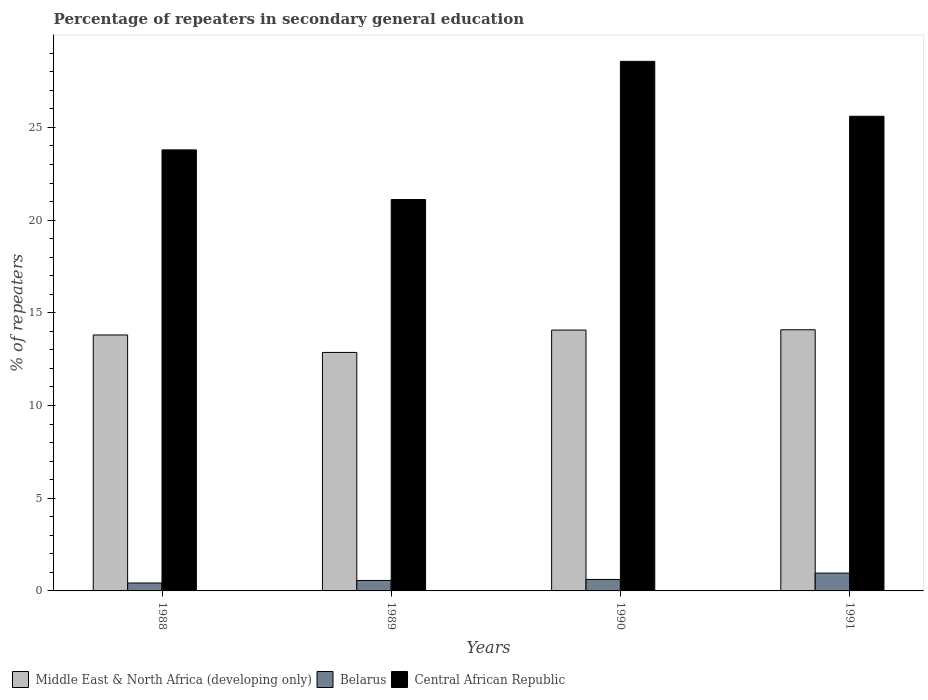How many different coloured bars are there?
Ensure brevity in your answer.  3. Are the number of bars per tick equal to the number of legend labels?
Give a very brief answer. Yes. What is the label of the 2nd group of bars from the left?
Make the answer very short. 1989. What is the percentage of repeaters in secondary general education in Belarus in 1991?
Offer a very short reply. 0.96. Across all years, what is the maximum percentage of repeaters in secondary general education in Central African Republic?
Your answer should be very brief. 28.56. Across all years, what is the minimum percentage of repeaters in secondary general education in Central African Republic?
Give a very brief answer. 21.11. In which year was the percentage of repeaters in secondary general education in Belarus minimum?
Your response must be concise. 1988. What is the total percentage of repeaters in secondary general education in Middle East & North Africa (developing only) in the graph?
Your answer should be very brief. 54.82. What is the difference between the percentage of repeaters in secondary general education in Middle East & North Africa (developing only) in 1988 and that in 1989?
Your answer should be very brief. 0.94. What is the difference between the percentage of repeaters in secondary general education in Middle East & North Africa (developing only) in 1991 and the percentage of repeaters in secondary general education in Belarus in 1990?
Your answer should be very brief. 13.47. What is the average percentage of repeaters in secondary general education in Belarus per year?
Offer a terse response. 0.64. In the year 1991, what is the difference between the percentage of repeaters in secondary general education in Central African Republic and percentage of repeaters in secondary general education in Middle East & North Africa (developing only)?
Your answer should be very brief. 11.52. What is the ratio of the percentage of repeaters in secondary general education in Central African Republic in 1989 to that in 1990?
Your answer should be compact. 0.74. Is the difference between the percentage of repeaters in secondary general education in Central African Republic in 1990 and 1991 greater than the difference between the percentage of repeaters in secondary general education in Middle East & North Africa (developing only) in 1990 and 1991?
Offer a very short reply. Yes. What is the difference between the highest and the second highest percentage of repeaters in secondary general education in Central African Republic?
Your answer should be very brief. 2.96. What is the difference between the highest and the lowest percentage of repeaters in secondary general education in Middle East & North Africa (developing only)?
Provide a short and direct response. 1.22. What does the 1st bar from the left in 1991 represents?
Provide a short and direct response. Middle East & North Africa (developing only). What does the 1st bar from the right in 1989 represents?
Give a very brief answer. Central African Republic. Is it the case that in every year, the sum of the percentage of repeaters in secondary general education in Middle East & North Africa (developing only) and percentage of repeaters in secondary general education in Belarus is greater than the percentage of repeaters in secondary general education in Central African Republic?
Your answer should be very brief. No. How many bars are there?
Ensure brevity in your answer.  12. Are the values on the major ticks of Y-axis written in scientific E-notation?
Your answer should be compact. No. Where does the legend appear in the graph?
Offer a very short reply. Bottom left. How are the legend labels stacked?
Your answer should be very brief. Horizontal. What is the title of the graph?
Your answer should be compact. Percentage of repeaters in secondary general education. Does "Cote d'Ivoire" appear as one of the legend labels in the graph?
Offer a very short reply. No. What is the label or title of the X-axis?
Ensure brevity in your answer.  Years. What is the label or title of the Y-axis?
Keep it short and to the point. % of repeaters. What is the % of repeaters in Middle East & North Africa (developing only) in 1988?
Make the answer very short. 13.8. What is the % of repeaters of Belarus in 1988?
Offer a very short reply. 0.43. What is the % of repeaters of Central African Republic in 1988?
Provide a short and direct response. 23.79. What is the % of repeaters in Middle East & North Africa (developing only) in 1989?
Provide a short and direct response. 12.86. What is the % of repeaters of Belarus in 1989?
Your answer should be very brief. 0.56. What is the % of repeaters of Central African Republic in 1989?
Make the answer very short. 21.11. What is the % of repeaters of Middle East & North Africa (developing only) in 1990?
Ensure brevity in your answer.  14.07. What is the % of repeaters in Belarus in 1990?
Your response must be concise. 0.62. What is the % of repeaters in Central African Republic in 1990?
Keep it short and to the point. 28.56. What is the % of repeaters in Middle East & North Africa (developing only) in 1991?
Offer a terse response. 14.09. What is the % of repeaters in Belarus in 1991?
Provide a succinct answer. 0.96. What is the % of repeaters in Central African Republic in 1991?
Keep it short and to the point. 25.6. Across all years, what is the maximum % of repeaters of Middle East & North Africa (developing only)?
Give a very brief answer. 14.09. Across all years, what is the maximum % of repeaters in Belarus?
Your response must be concise. 0.96. Across all years, what is the maximum % of repeaters of Central African Republic?
Keep it short and to the point. 28.56. Across all years, what is the minimum % of repeaters in Middle East & North Africa (developing only)?
Offer a very short reply. 12.86. Across all years, what is the minimum % of repeaters in Belarus?
Give a very brief answer. 0.43. Across all years, what is the minimum % of repeaters of Central African Republic?
Give a very brief answer. 21.11. What is the total % of repeaters in Middle East & North Africa (developing only) in the graph?
Make the answer very short. 54.82. What is the total % of repeaters of Belarus in the graph?
Ensure brevity in your answer.  2.57. What is the total % of repeaters in Central African Republic in the graph?
Make the answer very short. 99.06. What is the difference between the % of repeaters of Middle East & North Africa (developing only) in 1988 and that in 1989?
Give a very brief answer. 0.94. What is the difference between the % of repeaters of Belarus in 1988 and that in 1989?
Offer a very short reply. -0.14. What is the difference between the % of repeaters of Central African Republic in 1988 and that in 1989?
Give a very brief answer. 2.68. What is the difference between the % of repeaters in Middle East & North Africa (developing only) in 1988 and that in 1990?
Keep it short and to the point. -0.26. What is the difference between the % of repeaters in Belarus in 1988 and that in 1990?
Your answer should be compact. -0.19. What is the difference between the % of repeaters of Central African Republic in 1988 and that in 1990?
Your answer should be very brief. -4.78. What is the difference between the % of repeaters of Middle East & North Africa (developing only) in 1988 and that in 1991?
Give a very brief answer. -0.28. What is the difference between the % of repeaters in Belarus in 1988 and that in 1991?
Your answer should be compact. -0.53. What is the difference between the % of repeaters in Central African Republic in 1988 and that in 1991?
Your answer should be compact. -1.81. What is the difference between the % of repeaters of Middle East & North Africa (developing only) in 1989 and that in 1990?
Make the answer very short. -1.21. What is the difference between the % of repeaters in Belarus in 1989 and that in 1990?
Ensure brevity in your answer.  -0.05. What is the difference between the % of repeaters in Central African Republic in 1989 and that in 1990?
Your response must be concise. -7.45. What is the difference between the % of repeaters of Middle East & North Africa (developing only) in 1989 and that in 1991?
Give a very brief answer. -1.22. What is the difference between the % of repeaters of Belarus in 1989 and that in 1991?
Make the answer very short. -0.4. What is the difference between the % of repeaters in Central African Republic in 1989 and that in 1991?
Your answer should be very brief. -4.49. What is the difference between the % of repeaters of Middle East & North Africa (developing only) in 1990 and that in 1991?
Your answer should be compact. -0.02. What is the difference between the % of repeaters of Belarus in 1990 and that in 1991?
Offer a terse response. -0.34. What is the difference between the % of repeaters of Central African Republic in 1990 and that in 1991?
Make the answer very short. 2.96. What is the difference between the % of repeaters in Middle East & North Africa (developing only) in 1988 and the % of repeaters in Belarus in 1989?
Give a very brief answer. 13.24. What is the difference between the % of repeaters in Middle East & North Africa (developing only) in 1988 and the % of repeaters in Central African Republic in 1989?
Keep it short and to the point. -7.31. What is the difference between the % of repeaters in Belarus in 1988 and the % of repeaters in Central African Republic in 1989?
Offer a very short reply. -20.68. What is the difference between the % of repeaters of Middle East & North Africa (developing only) in 1988 and the % of repeaters of Belarus in 1990?
Give a very brief answer. 13.19. What is the difference between the % of repeaters in Middle East & North Africa (developing only) in 1988 and the % of repeaters in Central African Republic in 1990?
Make the answer very short. -14.76. What is the difference between the % of repeaters of Belarus in 1988 and the % of repeaters of Central African Republic in 1990?
Offer a terse response. -28.14. What is the difference between the % of repeaters in Middle East & North Africa (developing only) in 1988 and the % of repeaters in Belarus in 1991?
Your answer should be very brief. 12.84. What is the difference between the % of repeaters in Middle East & North Africa (developing only) in 1988 and the % of repeaters in Central African Republic in 1991?
Your answer should be compact. -11.8. What is the difference between the % of repeaters in Belarus in 1988 and the % of repeaters in Central African Republic in 1991?
Provide a short and direct response. -25.17. What is the difference between the % of repeaters of Middle East & North Africa (developing only) in 1989 and the % of repeaters of Belarus in 1990?
Keep it short and to the point. 12.24. What is the difference between the % of repeaters in Middle East & North Africa (developing only) in 1989 and the % of repeaters in Central African Republic in 1990?
Provide a short and direct response. -15.7. What is the difference between the % of repeaters in Belarus in 1989 and the % of repeaters in Central African Republic in 1990?
Provide a succinct answer. -28. What is the difference between the % of repeaters of Middle East & North Africa (developing only) in 1989 and the % of repeaters of Belarus in 1991?
Offer a terse response. 11.9. What is the difference between the % of repeaters of Middle East & North Africa (developing only) in 1989 and the % of repeaters of Central African Republic in 1991?
Give a very brief answer. -12.74. What is the difference between the % of repeaters in Belarus in 1989 and the % of repeaters in Central African Republic in 1991?
Make the answer very short. -25.04. What is the difference between the % of repeaters of Middle East & North Africa (developing only) in 1990 and the % of repeaters of Belarus in 1991?
Your answer should be compact. 13.11. What is the difference between the % of repeaters in Middle East & North Africa (developing only) in 1990 and the % of repeaters in Central African Republic in 1991?
Keep it short and to the point. -11.53. What is the difference between the % of repeaters in Belarus in 1990 and the % of repeaters in Central African Republic in 1991?
Keep it short and to the point. -24.98. What is the average % of repeaters in Middle East & North Africa (developing only) per year?
Your answer should be very brief. 13.71. What is the average % of repeaters of Belarus per year?
Make the answer very short. 0.64. What is the average % of repeaters in Central African Republic per year?
Provide a short and direct response. 24.77. In the year 1988, what is the difference between the % of repeaters of Middle East & North Africa (developing only) and % of repeaters of Belarus?
Offer a terse response. 13.38. In the year 1988, what is the difference between the % of repeaters of Middle East & North Africa (developing only) and % of repeaters of Central African Republic?
Give a very brief answer. -9.98. In the year 1988, what is the difference between the % of repeaters of Belarus and % of repeaters of Central African Republic?
Provide a succinct answer. -23.36. In the year 1989, what is the difference between the % of repeaters of Middle East & North Africa (developing only) and % of repeaters of Belarus?
Your response must be concise. 12.3. In the year 1989, what is the difference between the % of repeaters of Middle East & North Africa (developing only) and % of repeaters of Central African Republic?
Offer a very short reply. -8.25. In the year 1989, what is the difference between the % of repeaters in Belarus and % of repeaters in Central African Republic?
Your answer should be compact. -20.55. In the year 1990, what is the difference between the % of repeaters of Middle East & North Africa (developing only) and % of repeaters of Belarus?
Your response must be concise. 13.45. In the year 1990, what is the difference between the % of repeaters of Middle East & North Africa (developing only) and % of repeaters of Central African Republic?
Keep it short and to the point. -14.49. In the year 1990, what is the difference between the % of repeaters in Belarus and % of repeaters in Central African Republic?
Make the answer very short. -27.94. In the year 1991, what is the difference between the % of repeaters of Middle East & North Africa (developing only) and % of repeaters of Belarus?
Your answer should be very brief. 13.12. In the year 1991, what is the difference between the % of repeaters in Middle East & North Africa (developing only) and % of repeaters in Central African Republic?
Offer a very short reply. -11.52. In the year 1991, what is the difference between the % of repeaters of Belarus and % of repeaters of Central African Republic?
Ensure brevity in your answer.  -24.64. What is the ratio of the % of repeaters of Middle East & North Africa (developing only) in 1988 to that in 1989?
Offer a very short reply. 1.07. What is the ratio of the % of repeaters of Belarus in 1988 to that in 1989?
Your response must be concise. 0.76. What is the ratio of the % of repeaters in Central African Republic in 1988 to that in 1989?
Provide a short and direct response. 1.13. What is the ratio of the % of repeaters in Middle East & North Africa (developing only) in 1988 to that in 1990?
Your response must be concise. 0.98. What is the ratio of the % of repeaters in Belarus in 1988 to that in 1990?
Offer a terse response. 0.69. What is the ratio of the % of repeaters in Central African Republic in 1988 to that in 1990?
Your response must be concise. 0.83. What is the ratio of the % of repeaters in Middle East & North Africa (developing only) in 1988 to that in 1991?
Make the answer very short. 0.98. What is the ratio of the % of repeaters of Belarus in 1988 to that in 1991?
Keep it short and to the point. 0.45. What is the ratio of the % of repeaters in Central African Republic in 1988 to that in 1991?
Your answer should be very brief. 0.93. What is the ratio of the % of repeaters of Middle East & North Africa (developing only) in 1989 to that in 1990?
Your answer should be very brief. 0.91. What is the ratio of the % of repeaters in Belarus in 1989 to that in 1990?
Your response must be concise. 0.91. What is the ratio of the % of repeaters of Central African Republic in 1989 to that in 1990?
Your answer should be compact. 0.74. What is the ratio of the % of repeaters in Middle East & North Africa (developing only) in 1989 to that in 1991?
Offer a very short reply. 0.91. What is the ratio of the % of repeaters in Belarus in 1989 to that in 1991?
Offer a terse response. 0.59. What is the ratio of the % of repeaters of Central African Republic in 1989 to that in 1991?
Provide a short and direct response. 0.82. What is the ratio of the % of repeaters in Middle East & North Africa (developing only) in 1990 to that in 1991?
Ensure brevity in your answer.  1. What is the ratio of the % of repeaters of Belarus in 1990 to that in 1991?
Your answer should be very brief. 0.64. What is the ratio of the % of repeaters of Central African Republic in 1990 to that in 1991?
Offer a very short reply. 1.12. What is the difference between the highest and the second highest % of repeaters of Middle East & North Africa (developing only)?
Provide a short and direct response. 0.02. What is the difference between the highest and the second highest % of repeaters in Belarus?
Your response must be concise. 0.34. What is the difference between the highest and the second highest % of repeaters in Central African Republic?
Provide a succinct answer. 2.96. What is the difference between the highest and the lowest % of repeaters in Middle East & North Africa (developing only)?
Provide a succinct answer. 1.22. What is the difference between the highest and the lowest % of repeaters in Belarus?
Your answer should be compact. 0.53. What is the difference between the highest and the lowest % of repeaters of Central African Republic?
Your answer should be very brief. 7.45. 